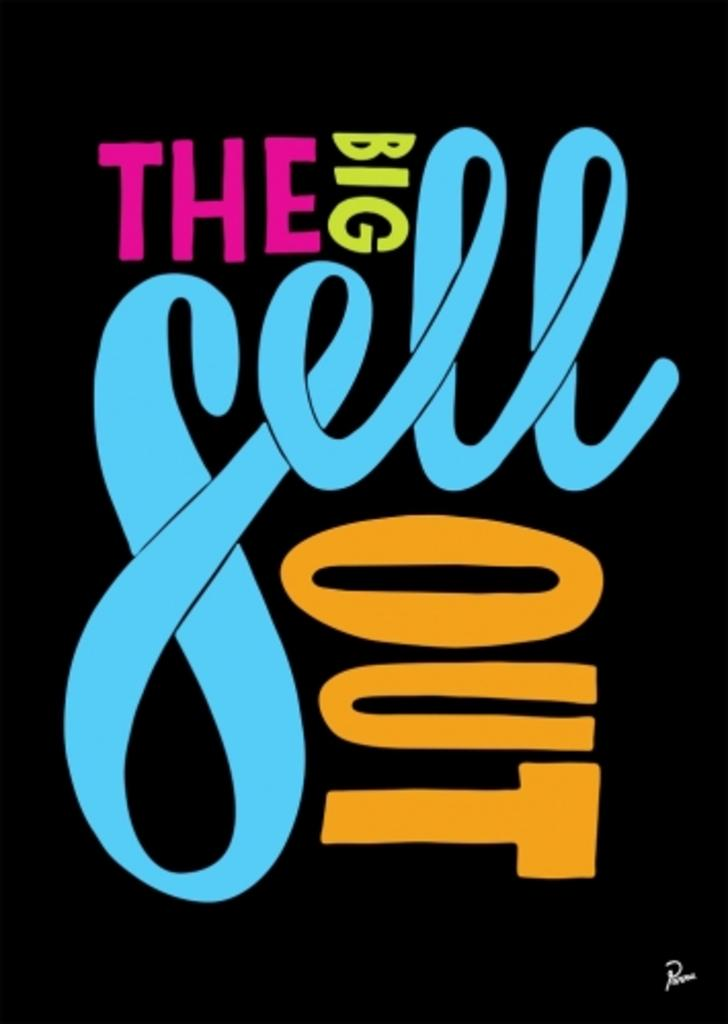Provide a one-sentence caption for the provided image. an orange word that says out and other words as well. 